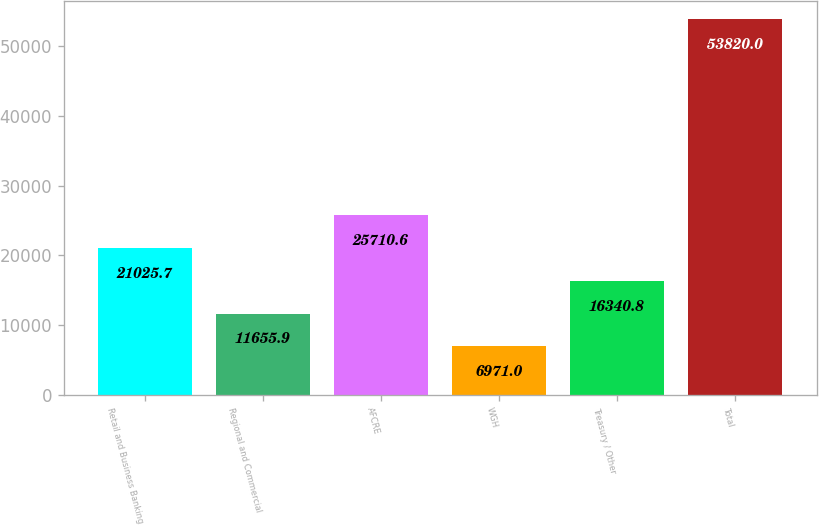Convert chart. <chart><loc_0><loc_0><loc_500><loc_500><bar_chart><fcel>Retail and Business Banking<fcel>Regional and Commercial<fcel>AFCRE<fcel>WGH<fcel>Treasury / Other<fcel>Total<nl><fcel>21025.7<fcel>11655.9<fcel>25710.6<fcel>6971<fcel>16340.8<fcel>53820<nl></chart> 